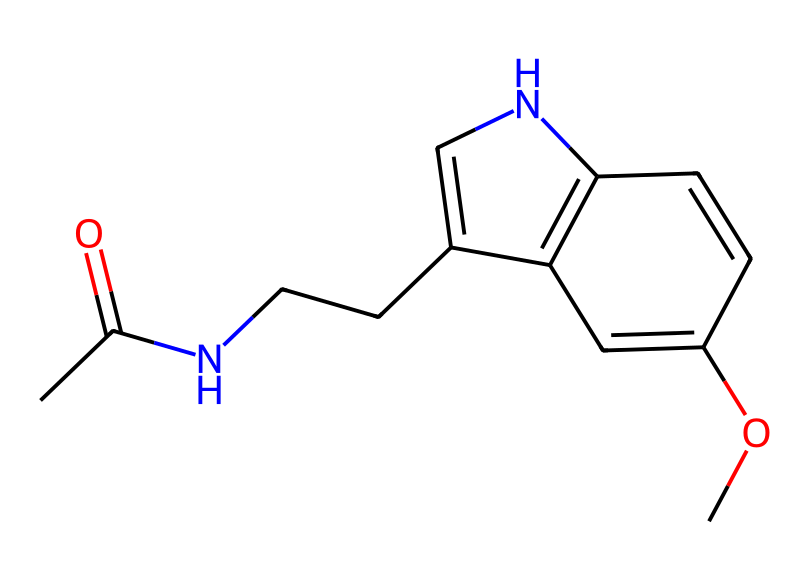What is the molecular formula of this compound? To determine the molecular formula, count the number of each type of atom present in the SMILES representation. The breakdown shows: 13 carbon (C) atoms, 16 hydrogen (H) atoms, 2 nitrogen (N) atoms, and 2 oxygen (O) atoms. Therefore, the molecular formula is C13H16N2O2.
Answer: C13H16N2O2 How many rings are present in this structure? By analyzing the SMILES representation, we identify two cyclic structures indicated by the numbers '1' and '2' which denote the start and end of rings. Counting these, we find there are two rings in the structure.
Answer: 2 What type of functional groups are present in this molecule? The presence of a carbonyl (C=O) and an ether (C-O-C) can be identified by examining the structure. The carbonyl group is indicated by "C(=O)" and the ether part is present as "C-O-C" in the molecular arrangement. Hence, the functional groups include an amide and an ether.
Answer: amide, ether What is the relationship between this molecule and immune function? Understanding the action of melatonin, which this structure corresponds to, is essential. Melatonin is known for its role in regulating circadian rhythms and also has immunomodulatory effects, influencing immune responses. Hence, the connection is through melatonin's biological functions.
Answer: immunomodulatory How does the structure of this compound suggest its biological activity? The multiple nitrogen atoms and the presence of functional groups (amide and ether) suggest potential interactions with biological receptors and systems. The specific arrangement allows this molecule to fit into receptors influencing sleep and immune modulation, highlighting its biological activity.
Answer: receptor interactions 